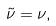Convert formula to latex. <formula><loc_0><loc_0><loc_500><loc_500>\tilde { \nu } = \nu ,</formula> 